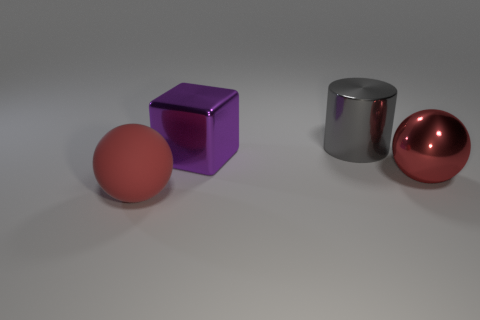Can you guess the purpose of these objects? These objects might be used for illustrative purposes, like in a 3D modeling or rendering software tutorial. They showcase how different textures and shapes can be represented digitally. 